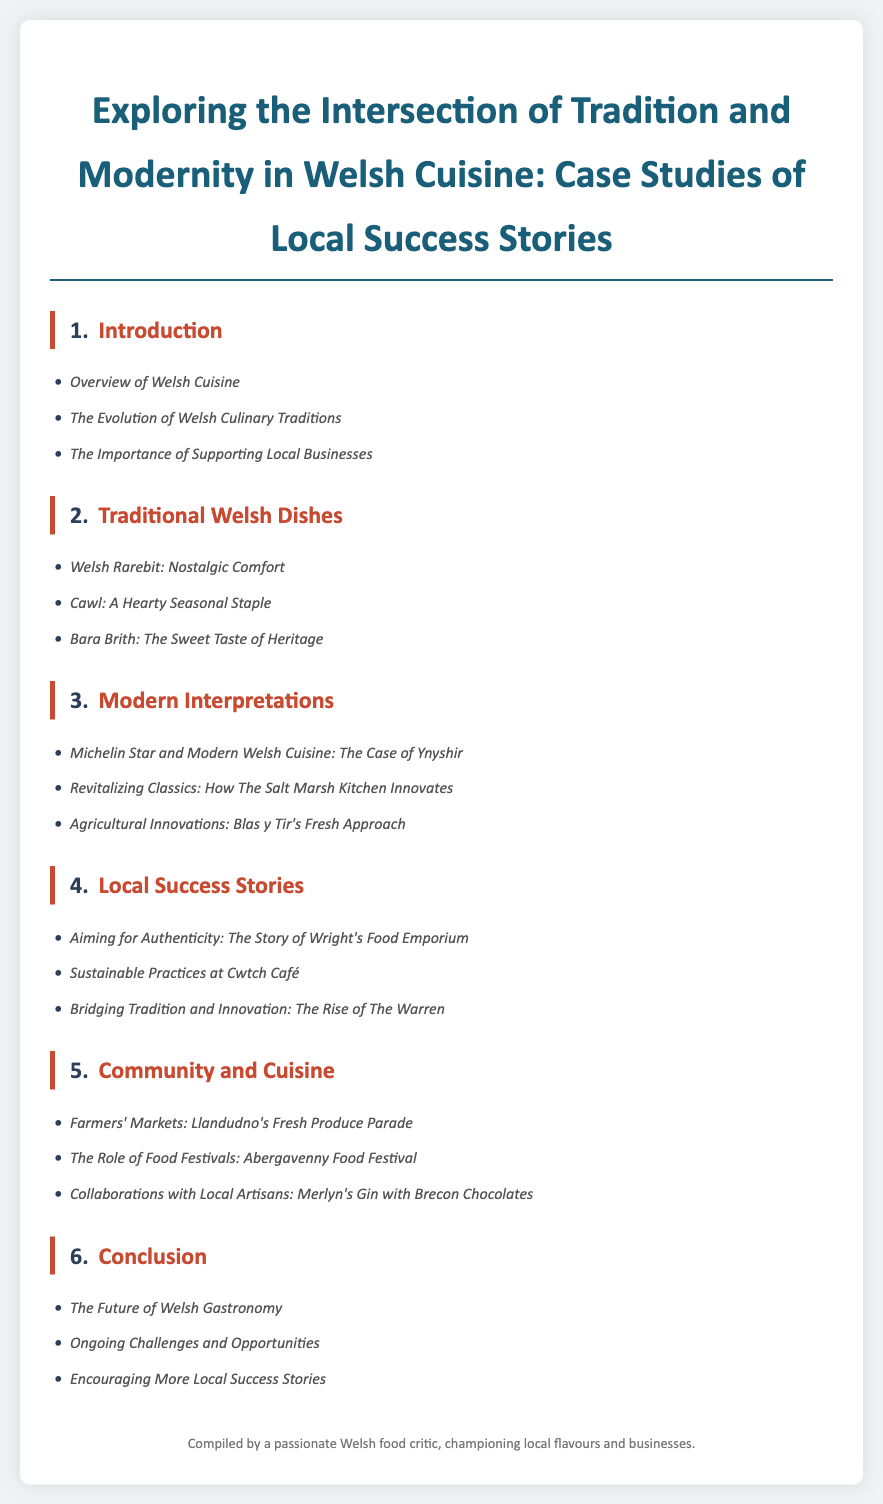what is the title of the document? The title provides the overall theme and focus of the document.
Answer: Exploring the Intersection of Tradition and Modernity in Welsh Cuisine: Case Studies of Local Success Stories how many chapters are in the document? The number of chapters indicates the structure of the document.
Answer: 6 name a traditional Welsh dish featured in the document. This requires recalling specific traditional dishes that are mentioned.
Answer: Welsh Rarebit which restaurant is a case study of modern Welsh cuisine? This asks for specific examples of establishments that represent modern interpretations of Welsh cuisine.
Answer: Ynyshir what is the focus of Chapter 5? This addresses the thematic focus of a specific chapter in the document.
Answer: Community and Cuisine who is the main audience for the document as mentioned in the footer? The footer indicates who compiled the document, reflecting its intended audience.
Answer: a passionate Welsh food critic which city is mentioned in the context of farmers' markets? This requires recalling specific locations mentioned in relation to community and cuisine.
Answer: Llandudno what is the concluding chapter about? The conclusion sums up the overall themes and findings of the document.
Answer: Conclusion name a sustainable practice discussed in the document. This targets specific examples of sustainable practices highlighted in the case studies.
Answer: Sustainable Practices at Cwtch Café 